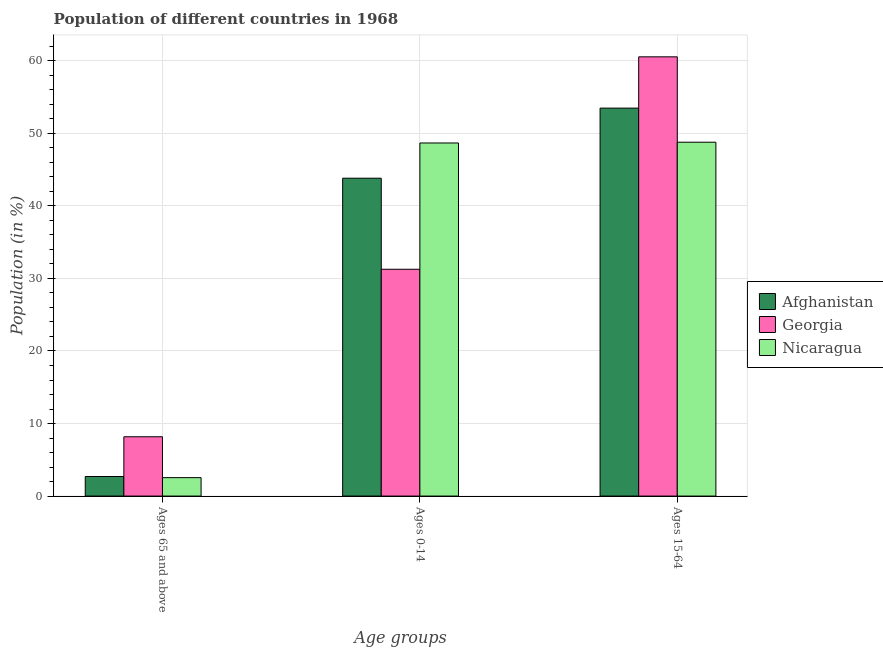Are the number of bars per tick equal to the number of legend labels?
Your response must be concise. Yes. Are the number of bars on each tick of the X-axis equal?
Keep it short and to the point. Yes. How many bars are there on the 2nd tick from the right?
Make the answer very short. 3. What is the label of the 3rd group of bars from the left?
Ensure brevity in your answer.  Ages 15-64. What is the percentage of population within the age-group of 65 and above in Georgia?
Your response must be concise. 8.18. Across all countries, what is the maximum percentage of population within the age-group 0-14?
Your answer should be very brief. 48.68. Across all countries, what is the minimum percentage of population within the age-group 15-64?
Ensure brevity in your answer.  48.78. In which country was the percentage of population within the age-group of 65 and above maximum?
Offer a very short reply. Georgia. In which country was the percentage of population within the age-group of 65 and above minimum?
Your answer should be very brief. Nicaragua. What is the total percentage of population within the age-group 0-14 in the graph?
Make the answer very short. 123.77. What is the difference between the percentage of population within the age-group of 65 and above in Georgia and that in Nicaragua?
Offer a very short reply. 5.64. What is the difference between the percentage of population within the age-group 15-64 in Nicaragua and the percentage of population within the age-group 0-14 in Afghanistan?
Make the answer very short. 4.96. What is the average percentage of population within the age-group 0-14 per country?
Ensure brevity in your answer.  41.26. What is the difference between the percentage of population within the age-group 15-64 and percentage of population within the age-group of 65 and above in Nicaragua?
Keep it short and to the point. 46.24. In how many countries, is the percentage of population within the age-group of 65 and above greater than 14 %?
Your answer should be compact. 0. What is the ratio of the percentage of population within the age-group 15-64 in Afghanistan to that in Nicaragua?
Provide a succinct answer. 1.1. Is the difference between the percentage of population within the age-group 15-64 in Nicaragua and Afghanistan greater than the difference between the percentage of population within the age-group of 65 and above in Nicaragua and Afghanistan?
Make the answer very short. No. What is the difference between the highest and the second highest percentage of population within the age-group 0-14?
Ensure brevity in your answer.  4.86. What is the difference between the highest and the lowest percentage of population within the age-group 0-14?
Make the answer very short. 17.41. What does the 2nd bar from the left in Ages 15-64 represents?
Ensure brevity in your answer.  Georgia. What does the 1st bar from the right in Ages 65 and above represents?
Make the answer very short. Nicaragua. Is it the case that in every country, the sum of the percentage of population within the age-group of 65 and above and percentage of population within the age-group 0-14 is greater than the percentage of population within the age-group 15-64?
Your answer should be very brief. No. How many countries are there in the graph?
Ensure brevity in your answer.  3. Are the values on the major ticks of Y-axis written in scientific E-notation?
Provide a short and direct response. No. Does the graph contain any zero values?
Ensure brevity in your answer.  No. Does the graph contain grids?
Your answer should be very brief. Yes. Where does the legend appear in the graph?
Your answer should be compact. Center right. How many legend labels are there?
Ensure brevity in your answer.  3. How are the legend labels stacked?
Your answer should be compact. Vertical. What is the title of the graph?
Your answer should be compact. Population of different countries in 1968. Does "Dominican Republic" appear as one of the legend labels in the graph?
Make the answer very short. No. What is the label or title of the X-axis?
Give a very brief answer. Age groups. What is the label or title of the Y-axis?
Ensure brevity in your answer.  Population (in %). What is the Population (in %) in Afghanistan in Ages 65 and above?
Ensure brevity in your answer.  2.7. What is the Population (in %) in Georgia in Ages 65 and above?
Provide a succinct answer. 8.18. What is the Population (in %) in Nicaragua in Ages 65 and above?
Ensure brevity in your answer.  2.54. What is the Population (in %) in Afghanistan in Ages 0-14?
Keep it short and to the point. 43.82. What is the Population (in %) of Georgia in Ages 0-14?
Offer a very short reply. 31.27. What is the Population (in %) in Nicaragua in Ages 0-14?
Keep it short and to the point. 48.68. What is the Population (in %) in Afghanistan in Ages 15-64?
Offer a very short reply. 53.48. What is the Population (in %) in Georgia in Ages 15-64?
Keep it short and to the point. 60.55. What is the Population (in %) in Nicaragua in Ages 15-64?
Provide a succinct answer. 48.78. Across all Age groups, what is the maximum Population (in %) of Afghanistan?
Offer a terse response. 53.48. Across all Age groups, what is the maximum Population (in %) in Georgia?
Provide a succinct answer. 60.55. Across all Age groups, what is the maximum Population (in %) of Nicaragua?
Offer a terse response. 48.78. Across all Age groups, what is the minimum Population (in %) in Afghanistan?
Your answer should be very brief. 2.7. Across all Age groups, what is the minimum Population (in %) in Georgia?
Ensure brevity in your answer.  8.18. Across all Age groups, what is the minimum Population (in %) in Nicaragua?
Keep it short and to the point. 2.54. What is the total Population (in %) of Afghanistan in the graph?
Give a very brief answer. 100. What is the difference between the Population (in %) in Afghanistan in Ages 65 and above and that in Ages 0-14?
Provide a short and direct response. -41.12. What is the difference between the Population (in %) of Georgia in Ages 65 and above and that in Ages 0-14?
Ensure brevity in your answer.  -23.09. What is the difference between the Population (in %) of Nicaragua in Ages 65 and above and that in Ages 0-14?
Offer a very short reply. -46.14. What is the difference between the Population (in %) in Afghanistan in Ages 65 and above and that in Ages 15-64?
Your answer should be compact. -50.79. What is the difference between the Population (in %) in Georgia in Ages 65 and above and that in Ages 15-64?
Make the answer very short. -52.38. What is the difference between the Population (in %) of Nicaragua in Ages 65 and above and that in Ages 15-64?
Keep it short and to the point. -46.24. What is the difference between the Population (in %) in Afghanistan in Ages 0-14 and that in Ages 15-64?
Your answer should be very brief. -9.66. What is the difference between the Population (in %) in Georgia in Ages 0-14 and that in Ages 15-64?
Give a very brief answer. -29.28. What is the difference between the Population (in %) of Nicaragua in Ages 0-14 and that in Ages 15-64?
Offer a terse response. -0.11. What is the difference between the Population (in %) in Afghanistan in Ages 65 and above and the Population (in %) in Georgia in Ages 0-14?
Make the answer very short. -28.57. What is the difference between the Population (in %) of Afghanistan in Ages 65 and above and the Population (in %) of Nicaragua in Ages 0-14?
Provide a short and direct response. -45.98. What is the difference between the Population (in %) in Georgia in Ages 65 and above and the Population (in %) in Nicaragua in Ages 0-14?
Your response must be concise. -40.5. What is the difference between the Population (in %) of Afghanistan in Ages 65 and above and the Population (in %) of Georgia in Ages 15-64?
Offer a terse response. -57.86. What is the difference between the Population (in %) in Afghanistan in Ages 65 and above and the Population (in %) in Nicaragua in Ages 15-64?
Ensure brevity in your answer.  -46.09. What is the difference between the Population (in %) in Georgia in Ages 65 and above and the Population (in %) in Nicaragua in Ages 15-64?
Give a very brief answer. -40.61. What is the difference between the Population (in %) of Afghanistan in Ages 0-14 and the Population (in %) of Georgia in Ages 15-64?
Offer a very short reply. -16.73. What is the difference between the Population (in %) in Afghanistan in Ages 0-14 and the Population (in %) in Nicaragua in Ages 15-64?
Offer a very short reply. -4.96. What is the difference between the Population (in %) in Georgia in Ages 0-14 and the Population (in %) in Nicaragua in Ages 15-64?
Offer a terse response. -17.51. What is the average Population (in %) in Afghanistan per Age groups?
Offer a very short reply. 33.33. What is the average Population (in %) in Georgia per Age groups?
Your answer should be compact. 33.33. What is the average Population (in %) of Nicaragua per Age groups?
Offer a very short reply. 33.33. What is the difference between the Population (in %) of Afghanistan and Population (in %) of Georgia in Ages 65 and above?
Provide a short and direct response. -5.48. What is the difference between the Population (in %) in Afghanistan and Population (in %) in Nicaragua in Ages 65 and above?
Your response must be concise. 0.16. What is the difference between the Population (in %) in Georgia and Population (in %) in Nicaragua in Ages 65 and above?
Keep it short and to the point. 5.64. What is the difference between the Population (in %) of Afghanistan and Population (in %) of Georgia in Ages 0-14?
Your answer should be very brief. 12.55. What is the difference between the Population (in %) of Afghanistan and Population (in %) of Nicaragua in Ages 0-14?
Offer a terse response. -4.86. What is the difference between the Population (in %) of Georgia and Population (in %) of Nicaragua in Ages 0-14?
Offer a very short reply. -17.41. What is the difference between the Population (in %) in Afghanistan and Population (in %) in Georgia in Ages 15-64?
Provide a succinct answer. -7.07. What is the difference between the Population (in %) of Afghanistan and Population (in %) of Nicaragua in Ages 15-64?
Your response must be concise. 4.7. What is the difference between the Population (in %) in Georgia and Population (in %) in Nicaragua in Ages 15-64?
Offer a terse response. 11.77. What is the ratio of the Population (in %) of Afghanistan in Ages 65 and above to that in Ages 0-14?
Offer a terse response. 0.06. What is the ratio of the Population (in %) of Georgia in Ages 65 and above to that in Ages 0-14?
Your response must be concise. 0.26. What is the ratio of the Population (in %) in Nicaragua in Ages 65 and above to that in Ages 0-14?
Your response must be concise. 0.05. What is the ratio of the Population (in %) of Afghanistan in Ages 65 and above to that in Ages 15-64?
Provide a succinct answer. 0.05. What is the ratio of the Population (in %) of Georgia in Ages 65 and above to that in Ages 15-64?
Your answer should be very brief. 0.14. What is the ratio of the Population (in %) in Nicaragua in Ages 65 and above to that in Ages 15-64?
Give a very brief answer. 0.05. What is the ratio of the Population (in %) of Afghanistan in Ages 0-14 to that in Ages 15-64?
Offer a very short reply. 0.82. What is the ratio of the Population (in %) of Georgia in Ages 0-14 to that in Ages 15-64?
Provide a succinct answer. 0.52. What is the ratio of the Population (in %) in Nicaragua in Ages 0-14 to that in Ages 15-64?
Your response must be concise. 1. What is the difference between the highest and the second highest Population (in %) of Afghanistan?
Your response must be concise. 9.66. What is the difference between the highest and the second highest Population (in %) in Georgia?
Your answer should be compact. 29.28. What is the difference between the highest and the second highest Population (in %) of Nicaragua?
Make the answer very short. 0.11. What is the difference between the highest and the lowest Population (in %) of Afghanistan?
Your answer should be very brief. 50.79. What is the difference between the highest and the lowest Population (in %) in Georgia?
Provide a short and direct response. 52.38. What is the difference between the highest and the lowest Population (in %) of Nicaragua?
Keep it short and to the point. 46.24. 